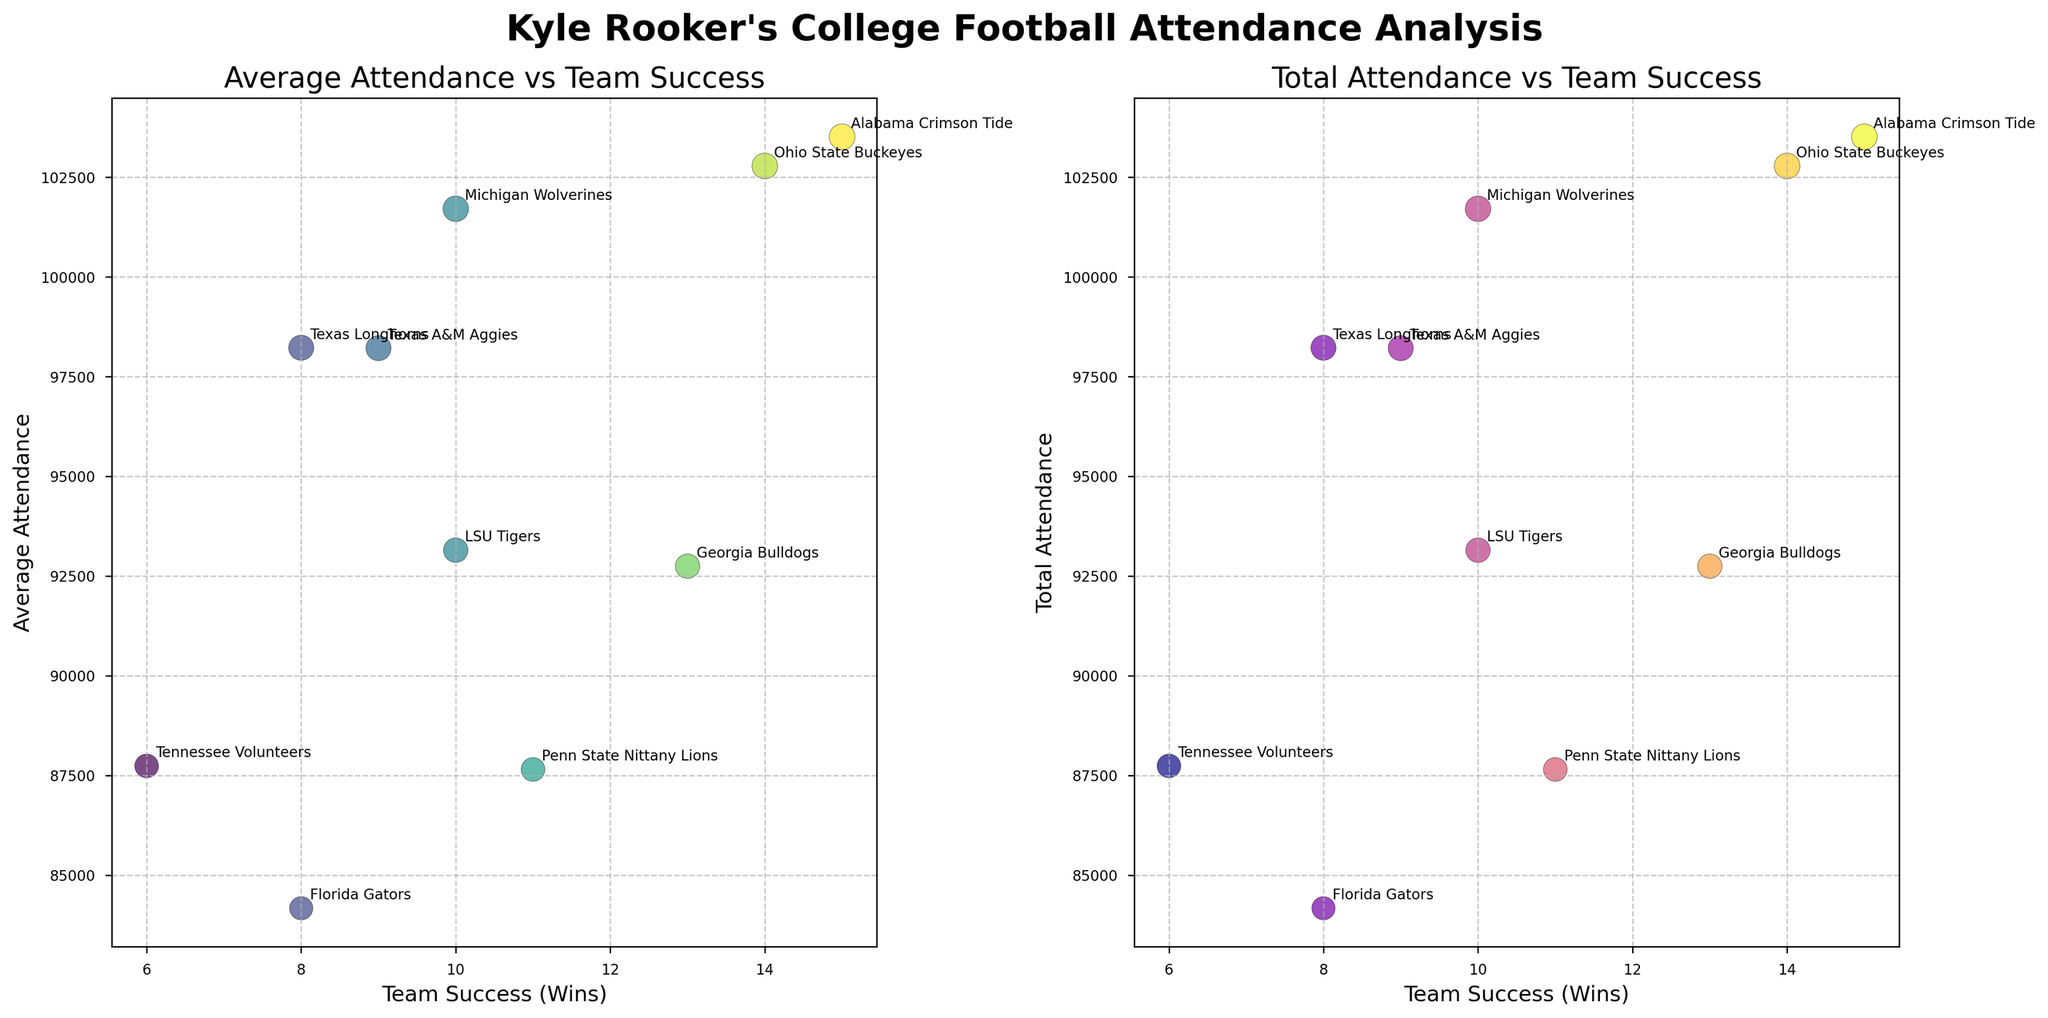What are the titles of the two subplots? The titles of the subplots are located above each scatter plot. The first subplot's title is "Average Attendance vs Team Success," and the second subplot's title is "Total Attendance vs Team Success."
Answer: "Average Attendance vs Team Success" and "Total Attendance vs Team Success" How many teams are represented in the figure? Each data point in the scatter plots represents one team. By counting the data points or checking the annotated team names, we find that there are 10 teams.
Answer: 10 What is the range of team success (wins) displayed in the figure? The range of team success can be determined by looking at the x-axis values for both subplots. The minimum number of wins is 6, and the maximum number of wins is 15.
Answer: 6 to 15 Which team has the highest average attendance? The scatter plot "Average Attendance vs Team Success" shows that the Alabama Crimson Tide has the highest value on the y-axis for average attendance.
Answer: Alabama Crimson Tide Does higher team success generally correlate with higher average attendance? By observing the scatter plot "Average Attendance vs Team Success," we see that teams with higher success (more wins) tend to have higher average attendance, indicating a positive correlation.
Answer: Yes Which team has the lowest total attendance, and what is their team success? The scatter plot "Total Attendance vs Team Success" shows that the Tennessee Volunteers have the lowest total attendance. Their number of wins, shown on the x-axis, is 6.
Answer: Tennessee Volunteers, 6 What is the average team success (wins) across all teams? To calculate the average team success, sum all the team wins and divide by the number of teams: (15 + 14 + 10 + 8 + 9 + 10 + 6 + 11 + 13 + 8)/10 = 10.4.
Answer: 10.4 Which teams have the same team success but different total attendance? By comparing data points, we observe that the Texas Longhorns and Florida Gators both have 8 wins but different total attendance values.
Answer: Texas Longhorns and Florida Gators Is there any team with a mismatch between average attendance and total attendance across the two subplots? The figure shows consistency; total attendance appears scaled properly in both subplots. No visible mismatch is observed for any teams regarding their attendance values.
Answer: No What could be a possible reason for a team having high team success but lower attendance than expected? A possible reason could be a smaller stadium capacity, limiting maximum attendance, or geographical and socio-economic factors affecting fan turnout.
Answer: Smaller stadium capacity or other factors 